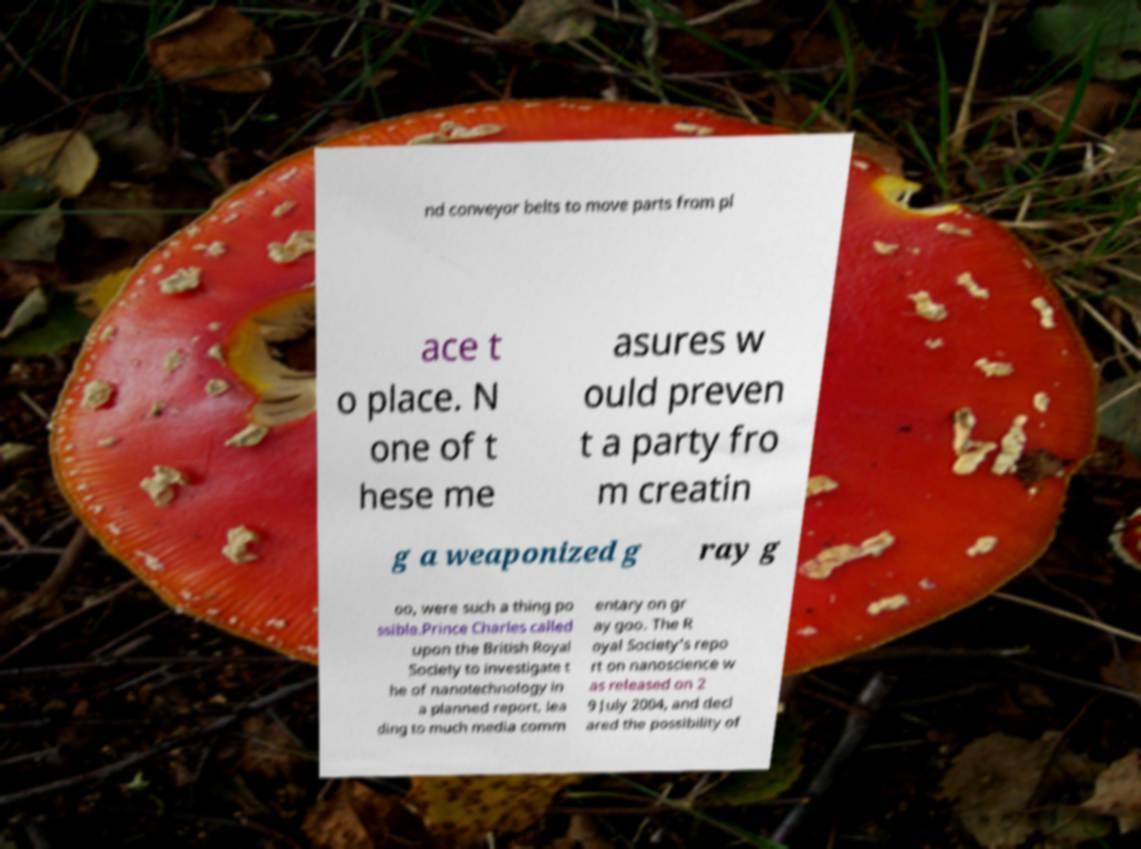Please read and relay the text visible in this image. What does it say? nd conveyor belts to move parts from pl ace t o place. N one of t hese me asures w ould preven t a party fro m creatin g a weaponized g ray g oo, were such a thing po ssible.Prince Charles called upon the British Royal Society to investigate t he of nanotechnology in a planned report, lea ding to much media comm entary on gr ay goo. The R oyal Society's repo rt on nanoscience w as released on 2 9 July 2004, and decl ared the possibility of 